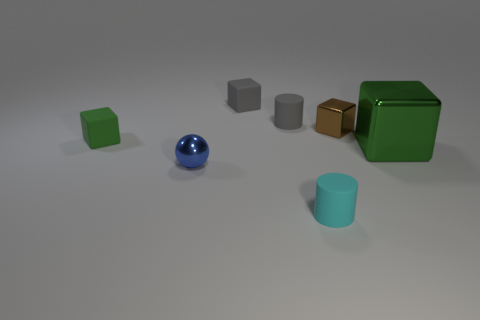Subtract all large cubes. How many cubes are left? 3 Subtract all balls. How many objects are left? 6 Subtract all brown cylinders. Subtract all brown spheres. How many cylinders are left? 2 Subtract all green balls. How many gray blocks are left? 1 Subtract all blue metallic balls. Subtract all blue spheres. How many objects are left? 5 Add 5 small brown metallic cubes. How many small brown metallic cubes are left? 6 Add 5 brown shiny cubes. How many brown shiny cubes exist? 6 Add 3 brown metallic objects. How many objects exist? 10 Subtract all gray cylinders. How many cylinders are left? 1 Subtract 1 blue spheres. How many objects are left? 6 